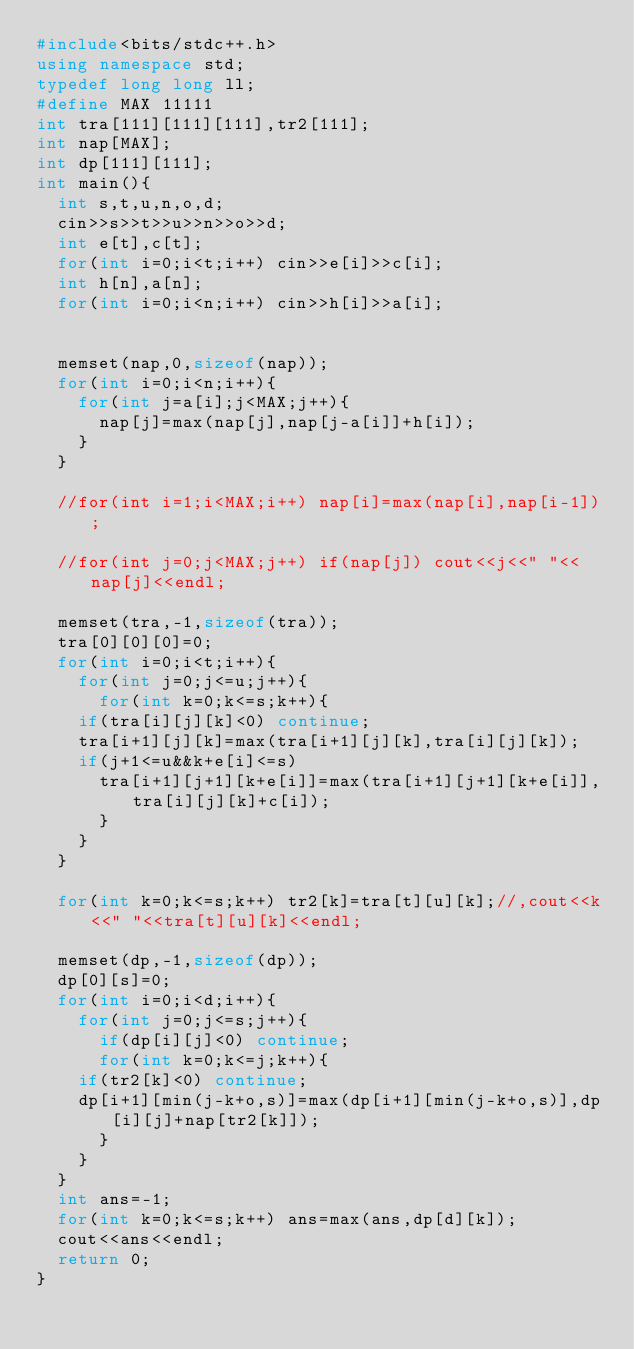Convert code to text. <code><loc_0><loc_0><loc_500><loc_500><_C++_>#include<bits/stdc++.h>
using namespace std;
typedef long long ll;
#define MAX 11111
int tra[111][111][111],tr2[111];
int nap[MAX];
int dp[111][111];
int main(){
  int s,t,u,n,o,d;
  cin>>s>>t>>u>>n>>o>>d;
  int e[t],c[t];
  for(int i=0;i<t;i++) cin>>e[i]>>c[i];
  int h[n],a[n];
  for(int i=0;i<n;i++) cin>>h[i]>>a[i];
   
  
  memset(nap,0,sizeof(nap));
  for(int i=0;i<n;i++){
    for(int j=a[i];j<MAX;j++){
      nap[j]=max(nap[j],nap[j-a[i]]+h[i]);
    }
  }
   
  //for(int i=1;i<MAX;i++) nap[i]=max(nap[i],nap[i-1]);
   
  //for(int j=0;j<MAX;j++) if(nap[j]) cout<<j<<" "<<nap[j]<<endl;
   
  memset(tra,-1,sizeof(tra));
  tra[0][0][0]=0;
  for(int i=0;i<t;i++){
    for(int j=0;j<=u;j++){
      for(int k=0;k<=s;k++){
    if(tra[i][j][k]<0) continue;
    tra[i+1][j][k]=max(tra[i+1][j][k],tra[i][j][k]);
    if(j+1<=u&&k+e[i]<=s) 
      tra[i+1][j+1][k+e[i]]=max(tra[i+1][j+1][k+e[i]],tra[i][j][k]+c[i]);
      }
    }
  }
   
  for(int k=0;k<=s;k++) tr2[k]=tra[t][u][k];//,cout<<k<<" "<<tra[t][u][k]<<endl;
 
  memset(dp,-1,sizeof(dp));
  dp[0][s]=0;
  for(int i=0;i<d;i++){
    for(int j=0;j<=s;j++){
      if(dp[i][j]<0) continue;
      for(int k=0;k<=j;k++){
    if(tr2[k]<0) continue;
    dp[i+1][min(j-k+o,s)]=max(dp[i+1][min(j-k+o,s)],dp[i][j]+nap[tr2[k]]);
      }
    }
  }
  int ans=-1;
  for(int k=0;k<=s;k++) ans=max(ans,dp[d][k]);
  cout<<ans<<endl;
  return 0;
}</code> 